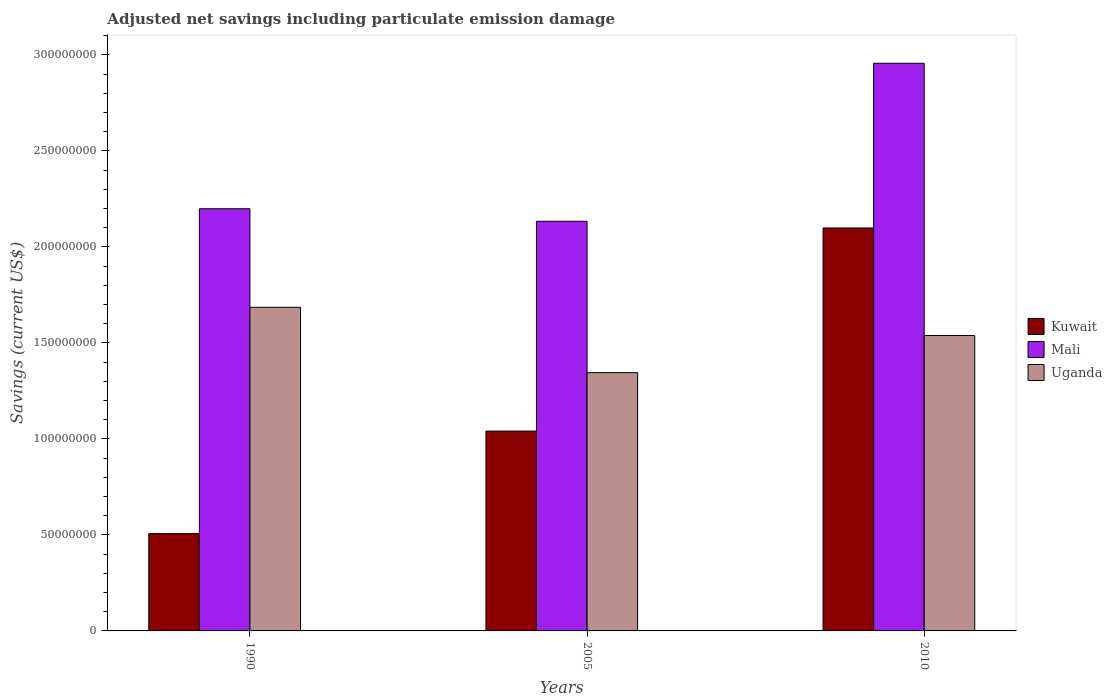Are the number of bars per tick equal to the number of legend labels?
Make the answer very short. Yes. Are the number of bars on each tick of the X-axis equal?
Keep it short and to the point. Yes. How many bars are there on the 2nd tick from the left?
Ensure brevity in your answer.  3. What is the net savings in Uganda in 2010?
Keep it short and to the point. 1.54e+08. Across all years, what is the maximum net savings in Mali?
Keep it short and to the point. 2.96e+08. Across all years, what is the minimum net savings in Uganda?
Provide a short and direct response. 1.34e+08. In which year was the net savings in Mali maximum?
Provide a succinct answer. 2010. In which year was the net savings in Mali minimum?
Your response must be concise. 2005. What is the total net savings in Uganda in the graph?
Give a very brief answer. 4.57e+08. What is the difference between the net savings in Uganda in 1990 and that in 2010?
Offer a very short reply. 1.47e+07. What is the difference between the net savings in Uganda in 2010 and the net savings in Mali in 2005?
Keep it short and to the point. -5.95e+07. What is the average net savings in Uganda per year?
Keep it short and to the point. 1.52e+08. In the year 2005, what is the difference between the net savings in Mali and net savings in Kuwait?
Provide a short and direct response. 1.09e+08. In how many years, is the net savings in Mali greater than 80000000 US$?
Provide a succinct answer. 3. What is the ratio of the net savings in Mali in 1990 to that in 2010?
Make the answer very short. 0.74. Is the net savings in Kuwait in 2005 less than that in 2010?
Keep it short and to the point. Yes. Is the difference between the net savings in Mali in 1990 and 2010 greater than the difference between the net savings in Kuwait in 1990 and 2010?
Offer a very short reply. Yes. What is the difference between the highest and the second highest net savings in Mali?
Provide a succinct answer. 7.58e+07. What is the difference between the highest and the lowest net savings in Uganda?
Ensure brevity in your answer.  3.41e+07. In how many years, is the net savings in Uganda greater than the average net savings in Uganda taken over all years?
Your answer should be compact. 2. Is the sum of the net savings in Kuwait in 1990 and 2005 greater than the maximum net savings in Mali across all years?
Ensure brevity in your answer.  No. What does the 1st bar from the left in 2010 represents?
Keep it short and to the point. Kuwait. What does the 3rd bar from the right in 2010 represents?
Ensure brevity in your answer.  Kuwait. Is it the case that in every year, the sum of the net savings in Kuwait and net savings in Uganda is greater than the net savings in Mali?
Provide a short and direct response. No. How many bars are there?
Ensure brevity in your answer.  9. Are the values on the major ticks of Y-axis written in scientific E-notation?
Provide a succinct answer. No. What is the title of the graph?
Your answer should be very brief. Adjusted net savings including particulate emission damage. What is the label or title of the Y-axis?
Your answer should be very brief. Savings (current US$). What is the Savings (current US$) in Kuwait in 1990?
Your response must be concise. 5.07e+07. What is the Savings (current US$) in Mali in 1990?
Make the answer very short. 2.20e+08. What is the Savings (current US$) of Uganda in 1990?
Give a very brief answer. 1.69e+08. What is the Savings (current US$) in Kuwait in 2005?
Offer a terse response. 1.04e+08. What is the Savings (current US$) of Mali in 2005?
Your response must be concise. 2.13e+08. What is the Savings (current US$) in Uganda in 2005?
Keep it short and to the point. 1.34e+08. What is the Savings (current US$) of Kuwait in 2010?
Give a very brief answer. 2.10e+08. What is the Savings (current US$) in Mali in 2010?
Ensure brevity in your answer.  2.96e+08. What is the Savings (current US$) of Uganda in 2010?
Your answer should be very brief. 1.54e+08. Across all years, what is the maximum Savings (current US$) in Kuwait?
Ensure brevity in your answer.  2.10e+08. Across all years, what is the maximum Savings (current US$) of Mali?
Your answer should be compact. 2.96e+08. Across all years, what is the maximum Savings (current US$) of Uganda?
Give a very brief answer. 1.69e+08. Across all years, what is the minimum Savings (current US$) in Kuwait?
Your answer should be very brief. 5.07e+07. Across all years, what is the minimum Savings (current US$) in Mali?
Your answer should be compact. 2.13e+08. Across all years, what is the minimum Savings (current US$) of Uganda?
Offer a terse response. 1.34e+08. What is the total Savings (current US$) of Kuwait in the graph?
Offer a terse response. 3.65e+08. What is the total Savings (current US$) in Mali in the graph?
Provide a short and direct response. 7.29e+08. What is the total Savings (current US$) of Uganda in the graph?
Provide a succinct answer. 4.57e+08. What is the difference between the Savings (current US$) of Kuwait in 1990 and that in 2005?
Provide a succinct answer. -5.34e+07. What is the difference between the Savings (current US$) of Mali in 1990 and that in 2005?
Provide a succinct answer. 6.53e+06. What is the difference between the Savings (current US$) of Uganda in 1990 and that in 2005?
Your answer should be very brief. 3.41e+07. What is the difference between the Savings (current US$) in Kuwait in 1990 and that in 2010?
Your answer should be very brief. -1.59e+08. What is the difference between the Savings (current US$) in Mali in 1990 and that in 2010?
Your answer should be compact. -7.58e+07. What is the difference between the Savings (current US$) of Uganda in 1990 and that in 2010?
Your answer should be compact. 1.47e+07. What is the difference between the Savings (current US$) in Kuwait in 2005 and that in 2010?
Give a very brief answer. -1.06e+08. What is the difference between the Savings (current US$) of Mali in 2005 and that in 2010?
Your answer should be very brief. -8.23e+07. What is the difference between the Savings (current US$) in Uganda in 2005 and that in 2010?
Provide a short and direct response. -1.93e+07. What is the difference between the Savings (current US$) in Kuwait in 1990 and the Savings (current US$) in Mali in 2005?
Your answer should be very brief. -1.63e+08. What is the difference between the Savings (current US$) in Kuwait in 1990 and the Savings (current US$) in Uganda in 2005?
Offer a terse response. -8.38e+07. What is the difference between the Savings (current US$) in Mali in 1990 and the Savings (current US$) in Uganda in 2005?
Your response must be concise. 8.54e+07. What is the difference between the Savings (current US$) in Kuwait in 1990 and the Savings (current US$) in Mali in 2010?
Offer a very short reply. -2.45e+08. What is the difference between the Savings (current US$) of Kuwait in 1990 and the Savings (current US$) of Uganda in 2010?
Keep it short and to the point. -1.03e+08. What is the difference between the Savings (current US$) in Mali in 1990 and the Savings (current US$) in Uganda in 2010?
Provide a short and direct response. 6.60e+07. What is the difference between the Savings (current US$) in Kuwait in 2005 and the Savings (current US$) in Mali in 2010?
Offer a very short reply. -1.92e+08. What is the difference between the Savings (current US$) in Kuwait in 2005 and the Savings (current US$) in Uganda in 2010?
Give a very brief answer. -4.98e+07. What is the difference between the Savings (current US$) in Mali in 2005 and the Savings (current US$) in Uganda in 2010?
Your response must be concise. 5.95e+07. What is the average Savings (current US$) of Kuwait per year?
Provide a short and direct response. 1.22e+08. What is the average Savings (current US$) in Mali per year?
Offer a terse response. 2.43e+08. What is the average Savings (current US$) in Uganda per year?
Keep it short and to the point. 1.52e+08. In the year 1990, what is the difference between the Savings (current US$) in Kuwait and Savings (current US$) in Mali?
Ensure brevity in your answer.  -1.69e+08. In the year 1990, what is the difference between the Savings (current US$) of Kuwait and Savings (current US$) of Uganda?
Offer a terse response. -1.18e+08. In the year 1990, what is the difference between the Savings (current US$) in Mali and Savings (current US$) in Uganda?
Provide a short and direct response. 5.13e+07. In the year 2005, what is the difference between the Savings (current US$) in Kuwait and Savings (current US$) in Mali?
Ensure brevity in your answer.  -1.09e+08. In the year 2005, what is the difference between the Savings (current US$) of Kuwait and Savings (current US$) of Uganda?
Ensure brevity in your answer.  -3.04e+07. In the year 2005, what is the difference between the Savings (current US$) in Mali and Savings (current US$) in Uganda?
Give a very brief answer. 7.88e+07. In the year 2010, what is the difference between the Savings (current US$) of Kuwait and Savings (current US$) of Mali?
Offer a terse response. -8.58e+07. In the year 2010, what is the difference between the Savings (current US$) of Kuwait and Savings (current US$) of Uganda?
Your response must be concise. 5.60e+07. In the year 2010, what is the difference between the Savings (current US$) of Mali and Savings (current US$) of Uganda?
Offer a terse response. 1.42e+08. What is the ratio of the Savings (current US$) in Kuwait in 1990 to that in 2005?
Offer a terse response. 0.49. What is the ratio of the Savings (current US$) of Mali in 1990 to that in 2005?
Give a very brief answer. 1.03. What is the ratio of the Savings (current US$) of Uganda in 1990 to that in 2005?
Offer a very short reply. 1.25. What is the ratio of the Savings (current US$) of Kuwait in 1990 to that in 2010?
Give a very brief answer. 0.24. What is the ratio of the Savings (current US$) of Mali in 1990 to that in 2010?
Give a very brief answer. 0.74. What is the ratio of the Savings (current US$) of Uganda in 1990 to that in 2010?
Keep it short and to the point. 1.1. What is the ratio of the Savings (current US$) in Kuwait in 2005 to that in 2010?
Provide a short and direct response. 0.5. What is the ratio of the Savings (current US$) in Mali in 2005 to that in 2010?
Your response must be concise. 0.72. What is the ratio of the Savings (current US$) of Uganda in 2005 to that in 2010?
Your answer should be compact. 0.87. What is the difference between the highest and the second highest Savings (current US$) in Kuwait?
Make the answer very short. 1.06e+08. What is the difference between the highest and the second highest Savings (current US$) of Mali?
Your answer should be very brief. 7.58e+07. What is the difference between the highest and the second highest Savings (current US$) of Uganda?
Provide a succinct answer. 1.47e+07. What is the difference between the highest and the lowest Savings (current US$) in Kuwait?
Your answer should be compact. 1.59e+08. What is the difference between the highest and the lowest Savings (current US$) of Mali?
Ensure brevity in your answer.  8.23e+07. What is the difference between the highest and the lowest Savings (current US$) of Uganda?
Your answer should be compact. 3.41e+07. 